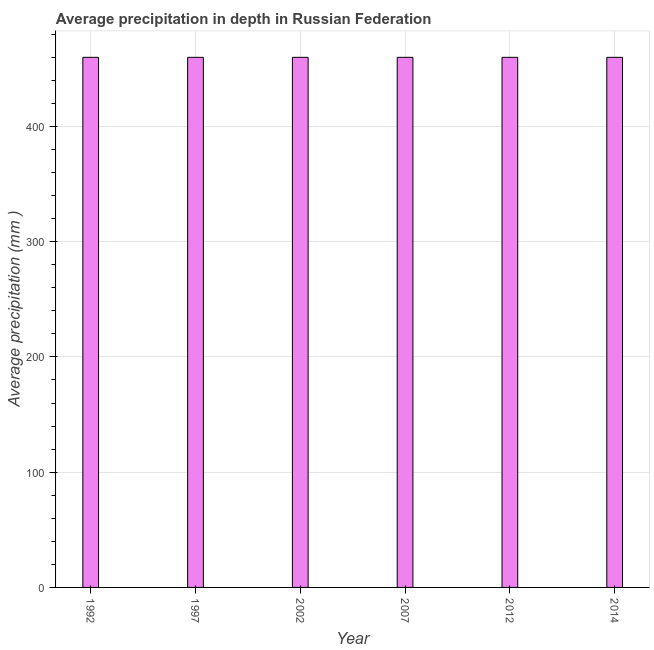Does the graph contain any zero values?
Offer a very short reply. No. Does the graph contain grids?
Your answer should be compact. Yes. What is the title of the graph?
Offer a terse response. Average precipitation in depth in Russian Federation. What is the label or title of the X-axis?
Your response must be concise. Year. What is the label or title of the Y-axis?
Give a very brief answer. Average precipitation (mm ). What is the average precipitation in depth in 2007?
Provide a short and direct response. 460. Across all years, what is the maximum average precipitation in depth?
Ensure brevity in your answer.  460. Across all years, what is the minimum average precipitation in depth?
Make the answer very short. 460. In which year was the average precipitation in depth minimum?
Ensure brevity in your answer.  1992. What is the sum of the average precipitation in depth?
Your answer should be very brief. 2760. What is the average average precipitation in depth per year?
Offer a very short reply. 460. What is the median average precipitation in depth?
Offer a very short reply. 460. What is the ratio of the average precipitation in depth in 1992 to that in 2012?
Offer a terse response. 1. Is the sum of the average precipitation in depth in 2002 and 2012 greater than the maximum average precipitation in depth across all years?
Provide a succinct answer. Yes. What is the difference between the highest and the lowest average precipitation in depth?
Ensure brevity in your answer.  0. How many bars are there?
Offer a very short reply. 6. Are the values on the major ticks of Y-axis written in scientific E-notation?
Ensure brevity in your answer.  No. What is the Average precipitation (mm ) of 1992?
Offer a terse response. 460. What is the Average precipitation (mm ) in 1997?
Offer a terse response. 460. What is the Average precipitation (mm ) of 2002?
Provide a succinct answer. 460. What is the Average precipitation (mm ) of 2007?
Your answer should be compact. 460. What is the Average precipitation (mm ) in 2012?
Provide a short and direct response. 460. What is the Average precipitation (mm ) in 2014?
Offer a terse response. 460. What is the difference between the Average precipitation (mm ) in 1992 and 2002?
Provide a succinct answer. 0. What is the difference between the Average precipitation (mm ) in 1992 and 2007?
Keep it short and to the point. 0. What is the difference between the Average precipitation (mm ) in 1997 and 2012?
Your answer should be compact. 0. What is the difference between the Average precipitation (mm ) in 2007 and 2012?
Give a very brief answer. 0. What is the difference between the Average precipitation (mm ) in 2007 and 2014?
Provide a succinct answer. 0. What is the difference between the Average precipitation (mm ) in 2012 and 2014?
Keep it short and to the point. 0. What is the ratio of the Average precipitation (mm ) in 1992 to that in 1997?
Keep it short and to the point. 1. What is the ratio of the Average precipitation (mm ) in 1992 to that in 2002?
Give a very brief answer. 1. What is the ratio of the Average precipitation (mm ) in 1992 to that in 2012?
Keep it short and to the point. 1. What is the ratio of the Average precipitation (mm ) in 1997 to that in 2002?
Ensure brevity in your answer.  1. What is the ratio of the Average precipitation (mm ) in 1997 to that in 2007?
Keep it short and to the point. 1. What is the ratio of the Average precipitation (mm ) in 1997 to that in 2012?
Ensure brevity in your answer.  1. What is the ratio of the Average precipitation (mm ) in 2002 to that in 2012?
Provide a short and direct response. 1. What is the ratio of the Average precipitation (mm ) in 2002 to that in 2014?
Ensure brevity in your answer.  1. What is the ratio of the Average precipitation (mm ) in 2007 to that in 2014?
Offer a very short reply. 1. What is the ratio of the Average precipitation (mm ) in 2012 to that in 2014?
Give a very brief answer. 1. 